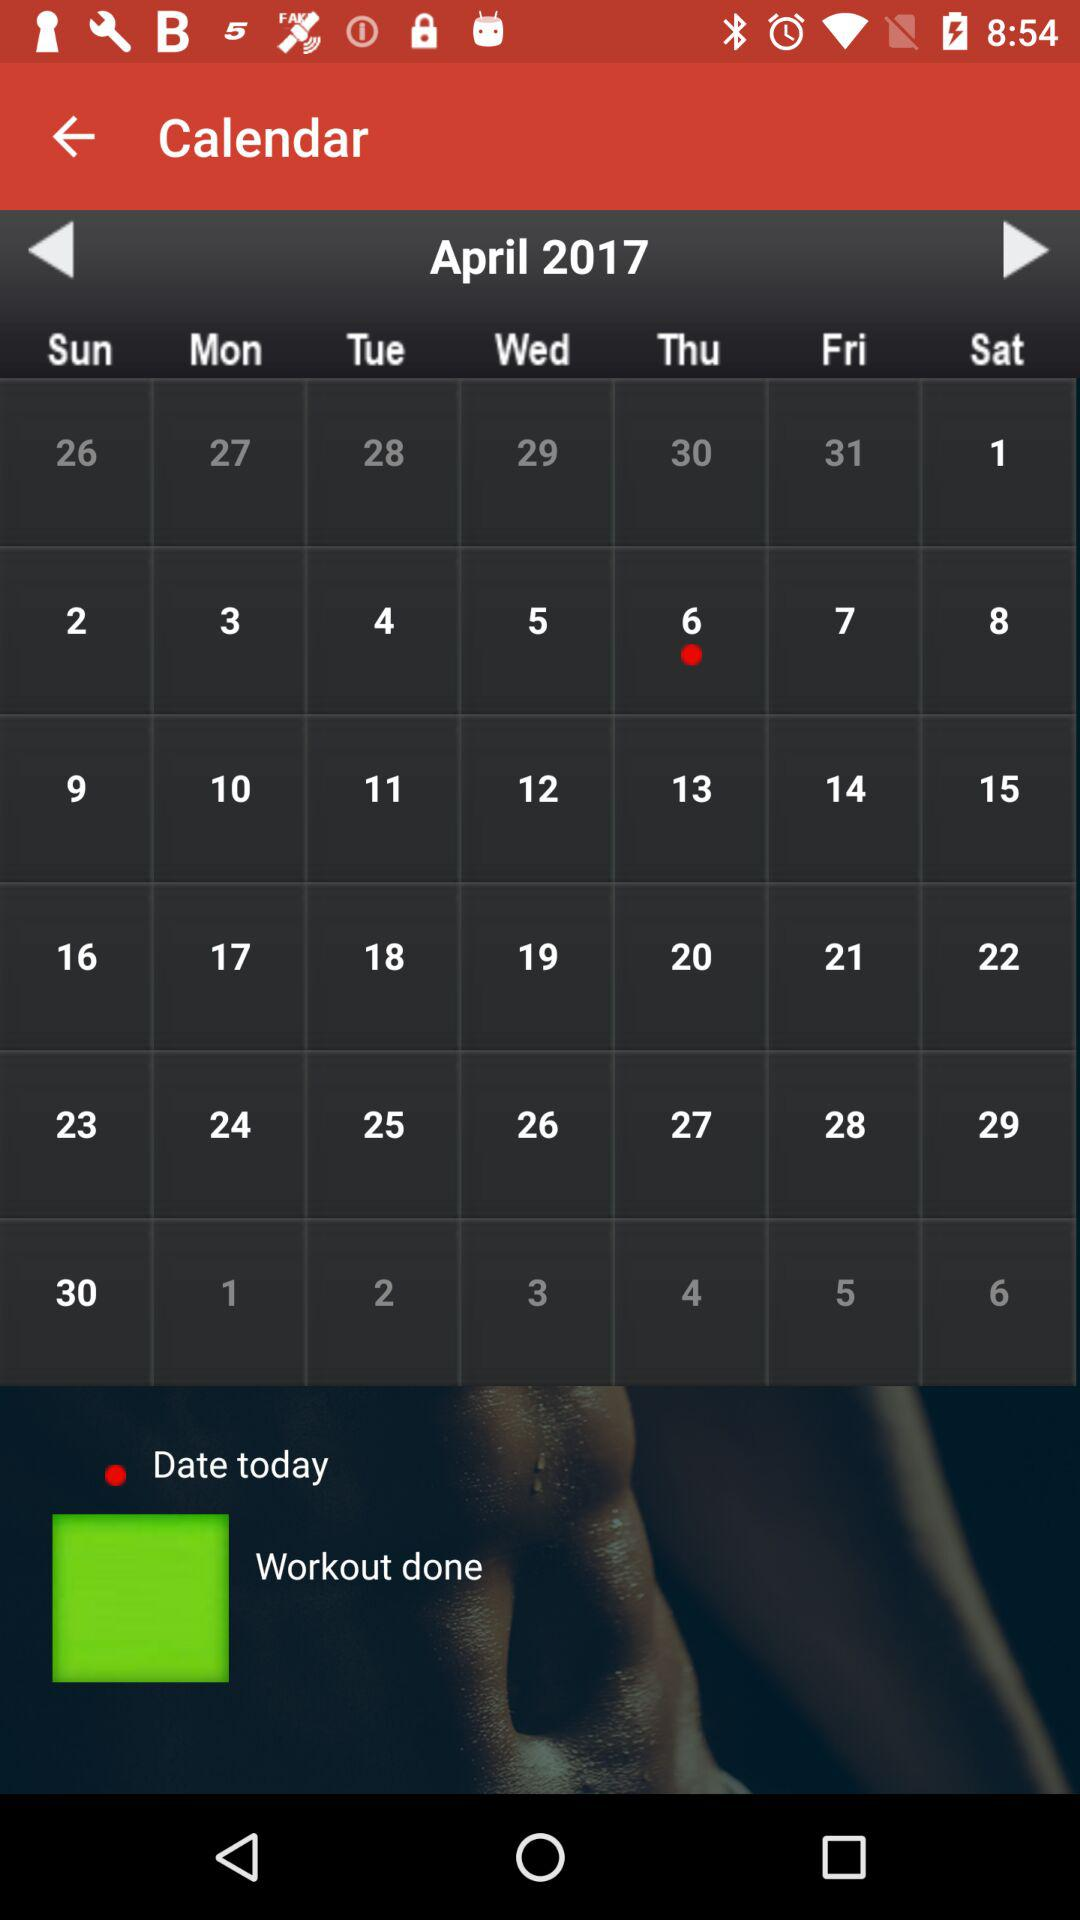Which date was selected for the workout? The selected date for the workout was Thursday, April 6, 2017. 